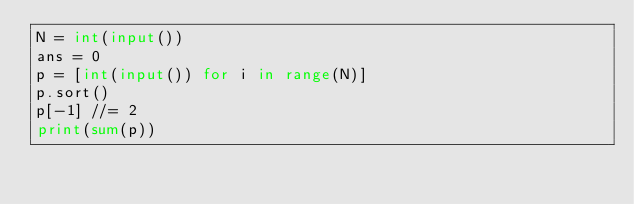<code> <loc_0><loc_0><loc_500><loc_500><_Python_>N = int(input())
ans = 0
p = [int(input()) for i in range(N)]
p.sort()
p[-1] //= 2
print(sum(p))</code> 